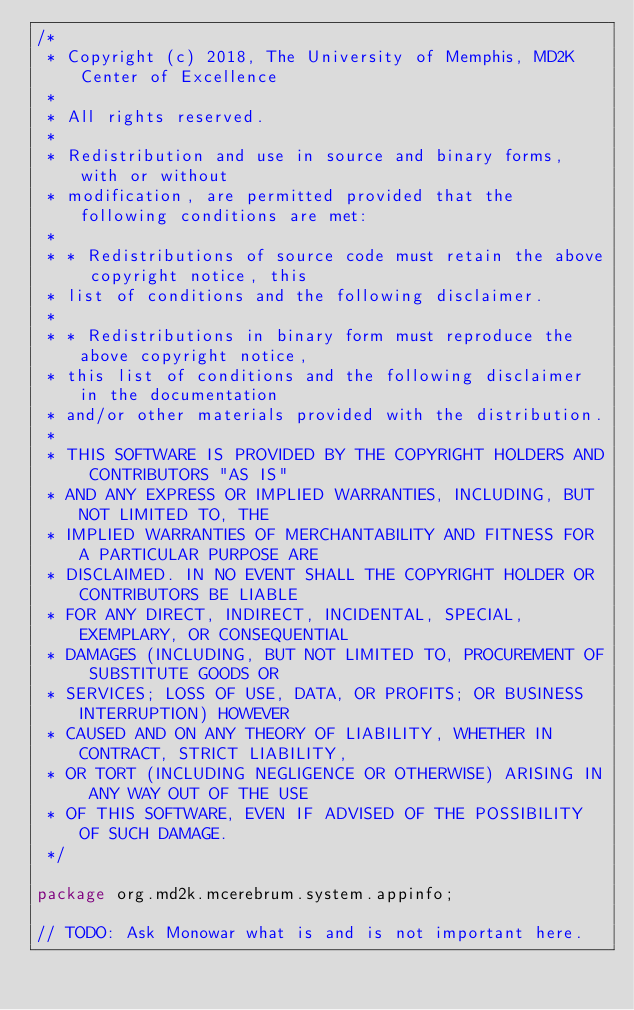<code> <loc_0><loc_0><loc_500><loc_500><_Java_>/*
 * Copyright (c) 2018, The University of Memphis, MD2K Center of Excellence
 *
 * All rights reserved.
 *
 * Redistribution and use in source and binary forms, with or without
 * modification, are permitted provided that the following conditions are met:
 *
 * * Redistributions of source code must retain the above copyright notice, this
 * list of conditions and the following disclaimer.
 *
 * * Redistributions in binary form must reproduce the above copyright notice,
 * this list of conditions and the following disclaimer in the documentation
 * and/or other materials provided with the distribution.
 *
 * THIS SOFTWARE IS PROVIDED BY THE COPYRIGHT HOLDERS AND CONTRIBUTORS "AS IS"
 * AND ANY EXPRESS OR IMPLIED WARRANTIES, INCLUDING, BUT NOT LIMITED TO, THE
 * IMPLIED WARRANTIES OF MERCHANTABILITY AND FITNESS FOR A PARTICULAR PURPOSE ARE
 * DISCLAIMED. IN NO EVENT SHALL THE COPYRIGHT HOLDER OR CONTRIBUTORS BE LIABLE
 * FOR ANY DIRECT, INDIRECT, INCIDENTAL, SPECIAL, EXEMPLARY, OR CONSEQUENTIAL
 * DAMAGES (INCLUDING, BUT NOT LIMITED TO, PROCUREMENT OF SUBSTITUTE GOODS OR
 * SERVICES; LOSS OF USE, DATA, OR PROFITS; OR BUSINESS INTERRUPTION) HOWEVER
 * CAUSED AND ON ANY THEORY OF LIABILITY, WHETHER IN CONTRACT, STRICT LIABILITY,
 * OR TORT (INCLUDING NEGLIGENCE OR OTHERWISE) ARISING IN ANY WAY OUT OF THE USE
 * OF THIS SOFTWARE, EVEN IF ADVISED OF THE POSSIBILITY OF SUCH DAMAGE.
 */

package org.md2k.mcerebrum.system.appinfo;

// TODO: Ask Monowar what is and is not important here.</code> 